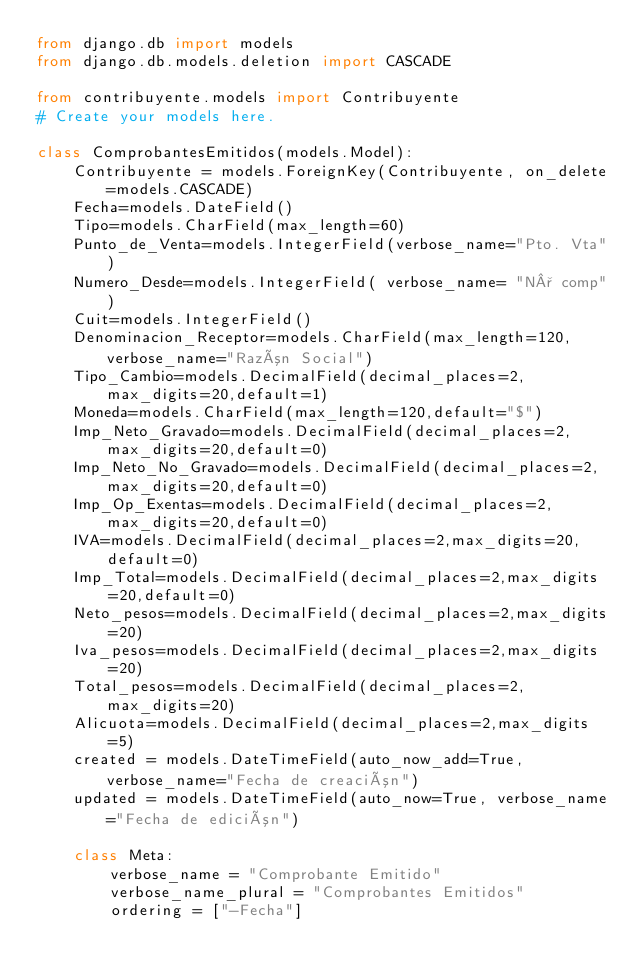<code> <loc_0><loc_0><loc_500><loc_500><_Python_>from django.db import models
from django.db.models.deletion import CASCADE

from contribuyente.models import Contribuyente
# Create your models here.

class ComprobantesEmitidos(models.Model):
    Contribuyente = models.ForeignKey(Contribuyente, on_delete=models.CASCADE)
    Fecha=models.DateField()
    Tipo=models.CharField(max_length=60)
    Punto_de_Venta=models.IntegerField(verbose_name="Pto. Vta")
    Numero_Desde=models.IntegerField( verbose_name= "N° comp")
    Cuit=models.IntegerField()
    Denominacion_Receptor=models.CharField(max_length=120, verbose_name="Razón Social")
    Tipo_Cambio=models.DecimalField(decimal_places=2,max_digits=20,default=1)
    Moneda=models.CharField(max_length=120,default="$")
    Imp_Neto_Gravado=models.DecimalField(decimal_places=2,max_digits=20,default=0)
    Imp_Neto_No_Gravado=models.DecimalField(decimal_places=2,max_digits=20,default=0)
    Imp_Op_Exentas=models.DecimalField(decimal_places=2,max_digits=20,default=0)
    IVA=models.DecimalField(decimal_places=2,max_digits=20,default=0)
    Imp_Total=models.DecimalField(decimal_places=2,max_digits=20,default=0)
    Neto_pesos=models.DecimalField(decimal_places=2,max_digits=20)
    Iva_pesos=models.DecimalField(decimal_places=2,max_digits=20)
    Total_pesos=models.DecimalField(decimal_places=2,max_digits=20)
    Alicuota=models.DecimalField(decimal_places=2,max_digits=5)
    created = models.DateTimeField(auto_now_add=True, verbose_name="Fecha de creación")
    updated = models.DateTimeField(auto_now=True, verbose_name="Fecha de edición")

    class Meta:
        verbose_name = "Comprobante Emitido"
        verbose_name_plural = "Comprobantes Emitidos"
        ordering = ["-Fecha"]
</code> 